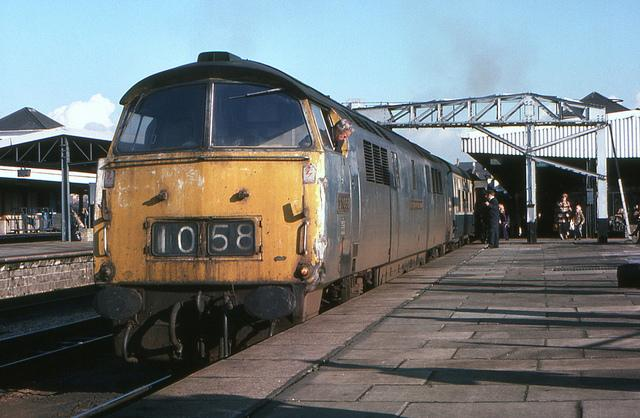What metro train number is this? 1058 